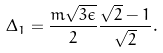Convert formula to latex. <formula><loc_0><loc_0><loc_500><loc_500>\Delta _ { 1 } = \frac { m \sqrt { 3 \epsilon } } { 2 } \frac { \sqrt { 2 } - 1 } { \sqrt { 2 } } .</formula> 